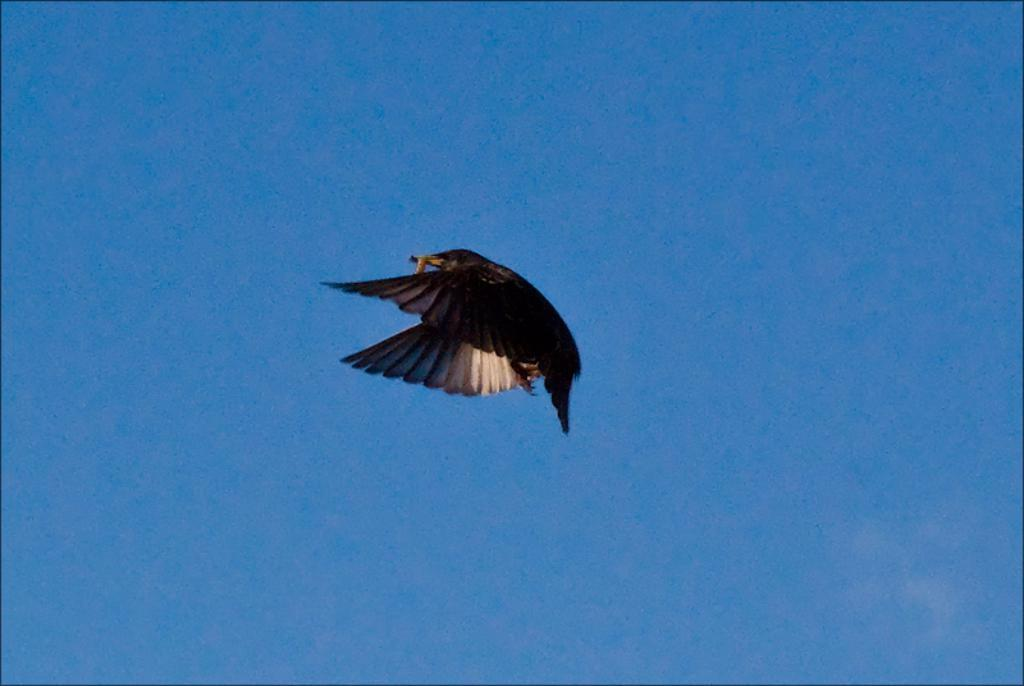What type of animal can be seen in the image? There is a bird in the image. What is the bird doing in the image? The bird is flying in the air. What can be seen in the background of the image? There is sky visible in the background of the image. What time of day is it in the image, given the quietness of the morning? The provided facts do not mention anything about the time of day or the quietness of the morning. The image only shows a bird flying in the sky. 